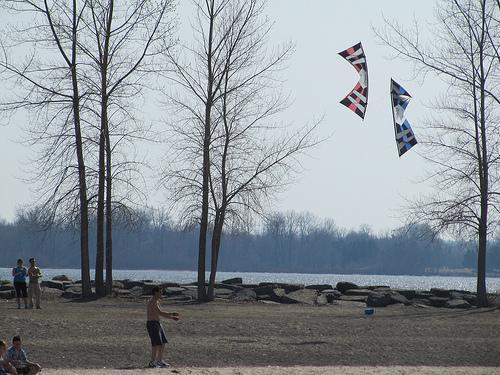How many flags are in the air?
Give a very brief answer. 2. 